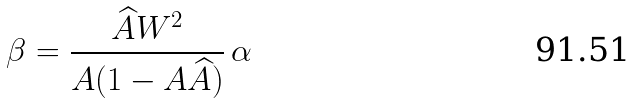Convert formula to latex. <formula><loc_0><loc_0><loc_500><loc_500>\beta = \frac { \widehat { A } W ^ { 2 } } { A ( 1 - A \widehat { A } ) } \, \alpha</formula> 